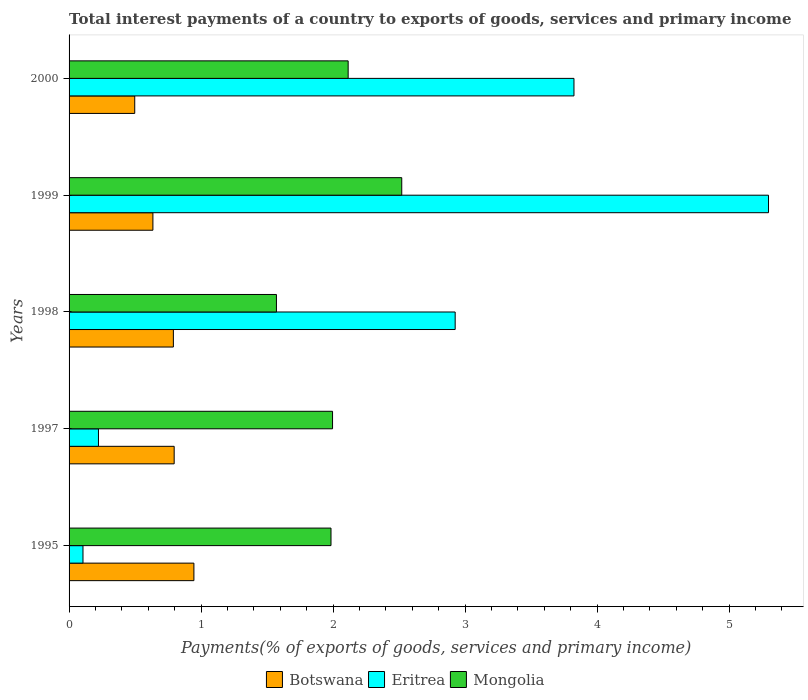How many different coloured bars are there?
Make the answer very short. 3. How many groups of bars are there?
Give a very brief answer. 5. Are the number of bars on each tick of the Y-axis equal?
Keep it short and to the point. Yes. How many bars are there on the 1st tick from the bottom?
Ensure brevity in your answer.  3. What is the total interest payments in Eritrea in 1995?
Provide a succinct answer. 0.11. Across all years, what is the maximum total interest payments in Mongolia?
Give a very brief answer. 2.52. Across all years, what is the minimum total interest payments in Mongolia?
Give a very brief answer. 1.57. In which year was the total interest payments in Mongolia maximum?
Your response must be concise. 1999. What is the total total interest payments in Eritrea in the graph?
Provide a short and direct response. 12.38. What is the difference between the total interest payments in Eritrea in 1998 and that in 2000?
Offer a terse response. -0.9. What is the difference between the total interest payments in Mongolia in 2000 and the total interest payments in Eritrea in 1995?
Keep it short and to the point. 2.01. What is the average total interest payments in Botswana per year?
Offer a very short reply. 0.73. In the year 1999, what is the difference between the total interest payments in Botswana and total interest payments in Eritrea?
Ensure brevity in your answer.  -4.66. What is the ratio of the total interest payments in Eritrea in 1997 to that in 2000?
Make the answer very short. 0.06. Is the total interest payments in Eritrea in 1997 less than that in 1998?
Your answer should be very brief. Yes. Is the difference between the total interest payments in Botswana in 1997 and 2000 greater than the difference between the total interest payments in Eritrea in 1997 and 2000?
Ensure brevity in your answer.  Yes. What is the difference between the highest and the second highest total interest payments in Botswana?
Your answer should be very brief. 0.15. What is the difference between the highest and the lowest total interest payments in Botswana?
Provide a short and direct response. 0.45. In how many years, is the total interest payments in Eritrea greater than the average total interest payments in Eritrea taken over all years?
Offer a terse response. 3. What does the 3rd bar from the top in 1995 represents?
Ensure brevity in your answer.  Botswana. What does the 1st bar from the bottom in 2000 represents?
Your answer should be compact. Botswana. Are all the bars in the graph horizontal?
Your answer should be very brief. Yes. How many years are there in the graph?
Give a very brief answer. 5. Are the values on the major ticks of X-axis written in scientific E-notation?
Keep it short and to the point. No. Does the graph contain any zero values?
Your answer should be very brief. No. What is the title of the graph?
Your answer should be very brief. Total interest payments of a country to exports of goods, services and primary income. Does "Paraguay" appear as one of the legend labels in the graph?
Provide a succinct answer. No. What is the label or title of the X-axis?
Provide a short and direct response. Payments(% of exports of goods, services and primary income). What is the Payments(% of exports of goods, services and primary income) in Botswana in 1995?
Provide a short and direct response. 0.95. What is the Payments(% of exports of goods, services and primary income) of Eritrea in 1995?
Offer a very short reply. 0.11. What is the Payments(% of exports of goods, services and primary income) of Mongolia in 1995?
Make the answer very short. 1.98. What is the Payments(% of exports of goods, services and primary income) in Botswana in 1997?
Your answer should be compact. 0.8. What is the Payments(% of exports of goods, services and primary income) in Eritrea in 1997?
Provide a short and direct response. 0.22. What is the Payments(% of exports of goods, services and primary income) in Mongolia in 1997?
Your response must be concise. 2. What is the Payments(% of exports of goods, services and primary income) of Botswana in 1998?
Keep it short and to the point. 0.79. What is the Payments(% of exports of goods, services and primary income) in Eritrea in 1998?
Give a very brief answer. 2.92. What is the Payments(% of exports of goods, services and primary income) of Mongolia in 1998?
Ensure brevity in your answer.  1.57. What is the Payments(% of exports of goods, services and primary income) in Botswana in 1999?
Provide a succinct answer. 0.64. What is the Payments(% of exports of goods, services and primary income) in Eritrea in 1999?
Your answer should be very brief. 5.3. What is the Payments(% of exports of goods, services and primary income) of Mongolia in 1999?
Your response must be concise. 2.52. What is the Payments(% of exports of goods, services and primary income) of Botswana in 2000?
Provide a short and direct response. 0.5. What is the Payments(% of exports of goods, services and primary income) of Eritrea in 2000?
Provide a succinct answer. 3.82. What is the Payments(% of exports of goods, services and primary income) in Mongolia in 2000?
Provide a succinct answer. 2.11. Across all years, what is the maximum Payments(% of exports of goods, services and primary income) in Botswana?
Your response must be concise. 0.95. Across all years, what is the maximum Payments(% of exports of goods, services and primary income) in Eritrea?
Your response must be concise. 5.3. Across all years, what is the maximum Payments(% of exports of goods, services and primary income) of Mongolia?
Give a very brief answer. 2.52. Across all years, what is the minimum Payments(% of exports of goods, services and primary income) in Botswana?
Offer a terse response. 0.5. Across all years, what is the minimum Payments(% of exports of goods, services and primary income) in Eritrea?
Give a very brief answer. 0.11. Across all years, what is the minimum Payments(% of exports of goods, services and primary income) in Mongolia?
Provide a short and direct response. 1.57. What is the total Payments(% of exports of goods, services and primary income) of Botswana in the graph?
Keep it short and to the point. 3.66. What is the total Payments(% of exports of goods, services and primary income) in Eritrea in the graph?
Give a very brief answer. 12.38. What is the total Payments(% of exports of goods, services and primary income) of Mongolia in the graph?
Make the answer very short. 10.19. What is the difference between the Payments(% of exports of goods, services and primary income) of Botswana in 1995 and that in 1997?
Provide a succinct answer. 0.15. What is the difference between the Payments(% of exports of goods, services and primary income) in Eritrea in 1995 and that in 1997?
Your response must be concise. -0.12. What is the difference between the Payments(% of exports of goods, services and primary income) in Mongolia in 1995 and that in 1997?
Provide a succinct answer. -0.01. What is the difference between the Payments(% of exports of goods, services and primary income) of Botswana in 1995 and that in 1998?
Your response must be concise. 0.16. What is the difference between the Payments(% of exports of goods, services and primary income) in Eritrea in 1995 and that in 1998?
Offer a terse response. -2.82. What is the difference between the Payments(% of exports of goods, services and primary income) of Mongolia in 1995 and that in 1998?
Give a very brief answer. 0.41. What is the difference between the Payments(% of exports of goods, services and primary income) of Botswana in 1995 and that in 1999?
Your answer should be compact. 0.31. What is the difference between the Payments(% of exports of goods, services and primary income) of Eritrea in 1995 and that in 1999?
Provide a short and direct response. -5.19. What is the difference between the Payments(% of exports of goods, services and primary income) in Mongolia in 1995 and that in 1999?
Offer a very short reply. -0.54. What is the difference between the Payments(% of exports of goods, services and primary income) in Botswana in 1995 and that in 2000?
Ensure brevity in your answer.  0.45. What is the difference between the Payments(% of exports of goods, services and primary income) of Eritrea in 1995 and that in 2000?
Make the answer very short. -3.72. What is the difference between the Payments(% of exports of goods, services and primary income) in Mongolia in 1995 and that in 2000?
Make the answer very short. -0.13. What is the difference between the Payments(% of exports of goods, services and primary income) in Botswana in 1997 and that in 1998?
Make the answer very short. 0.01. What is the difference between the Payments(% of exports of goods, services and primary income) in Eritrea in 1997 and that in 1998?
Your answer should be compact. -2.7. What is the difference between the Payments(% of exports of goods, services and primary income) of Mongolia in 1997 and that in 1998?
Your answer should be compact. 0.43. What is the difference between the Payments(% of exports of goods, services and primary income) in Botswana in 1997 and that in 1999?
Offer a terse response. 0.16. What is the difference between the Payments(% of exports of goods, services and primary income) of Eritrea in 1997 and that in 1999?
Offer a terse response. -5.08. What is the difference between the Payments(% of exports of goods, services and primary income) of Mongolia in 1997 and that in 1999?
Make the answer very short. -0.52. What is the difference between the Payments(% of exports of goods, services and primary income) in Botswana in 1997 and that in 2000?
Your answer should be compact. 0.3. What is the difference between the Payments(% of exports of goods, services and primary income) in Eritrea in 1997 and that in 2000?
Provide a short and direct response. -3.6. What is the difference between the Payments(% of exports of goods, services and primary income) of Mongolia in 1997 and that in 2000?
Your answer should be very brief. -0.12. What is the difference between the Payments(% of exports of goods, services and primary income) in Botswana in 1998 and that in 1999?
Make the answer very short. 0.16. What is the difference between the Payments(% of exports of goods, services and primary income) in Eritrea in 1998 and that in 1999?
Your answer should be very brief. -2.37. What is the difference between the Payments(% of exports of goods, services and primary income) of Mongolia in 1998 and that in 1999?
Offer a very short reply. -0.95. What is the difference between the Payments(% of exports of goods, services and primary income) of Botswana in 1998 and that in 2000?
Offer a terse response. 0.29. What is the difference between the Payments(% of exports of goods, services and primary income) of Eritrea in 1998 and that in 2000?
Offer a very short reply. -0.9. What is the difference between the Payments(% of exports of goods, services and primary income) of Mongolia in 1998 and that in 2000?
Your response must be concise. -0.54. What is the difference between the Payments(% of exports of goods, services and primary income) in Botswana in 1999 and that in 2000?
Your answer should be compact. 0.14. What is the difference between the Payments(% of exports of goods, services and primary income) of Eritrea in 1999 and that in 2000?
Ensure brevity in your answer.  1.47. What is the difference between the Payments(% of exports of goods, services and primary income) of Mongolia in 1999 and that in 2000?
Provide a succinct answer. 0.41. What is the difference between the Payments(% of exports of goods, services and primary income) in Botswana in 1995 and the Payments(% of exports of goods, services and primary income) in Eritrea in 1997?
Your answer should be very brief. 0.72. What is the difference between the Payments(% of exports of goods, services and primary income) of Botswana in 1995 and the Payments(% of exports of goods, services and primary income) of Mongolia in 1997?
Offer a terse response. -1.05. What is the difference between the Payments(% of exports of goods, services and primary income) of Eritrea in 1995 and the Payments(% of exports of goods, services and primary income) of Mongolia in 1997?
Make the answer very short. -1.89. What is the difference between the Payments(% of exports of goods, services and primary income) of Botswana in 1995 and the Payments(% of exports of goods, services and primary income) of Eritrea in 1998?
Offer a very short reply. -1.98. What is the difference between the Payments(% of exports of goods, services and primary income) of Botswana in 1995 and the Payments(% of exports of goods, services and primary income) of Mongolia in 1998?
Your answer should be compact. -0.63. What is the difference between the Payments(% of exports of goods, services and primary income) of Eritrea in 1995 and the Payments(% of exports of goods, services and primary income) of Mongolia in 1998?
Keep it short and to the point. -1.47. What is the difference between the Payments(% of exports of goods, services and primary income) of Botswana in 1995 and the Payments(% of exports of goods, services and primary income) of Eritrea in 1999?
Keep it short and to the point. -4.35. What is the difference between the Payments(% of exports of goods, services and primary income) in Botswana in 1995 and the Payments(% of exports of goods, services and primary income) in Mongolia in 1999?
Provide a short and direct response. -1.57. What is the difference between the Payments(% of exports of goods, services and primary income) in Eritrea in 1995 and the Payments(% of exports of goods, services and primary income) in Mongolia in 1999?
Provide a succinct answer. -2.41. What is the difference between the Payments(% of exports of goods, services and primary income) in Botswana in 1995 and the Payments(% of exports of goods, services and primary income) in Eritrea in 2000?
Provide a succinct answer. -2.88. What is the difference between the Payments(% of exports of goods, services and primary income) of Botswana in 1995 and the Payments(% of exports of goods, services and primary income) of Mongolia in 2000?
Offer a very short reply. -1.17. What is the difference between the Payments(% of exports of goods, services and primary income) in Eritrea in 1995 and the Payments(% of exports of goods, services and primary income) in Mongolia in 2000?
Offer a terse response. -2.01. What is the difference between the Payments(% of exports of goods, services and primary income) in Botswana in 1997 and the Payments(% of exports of goods, services and primary income) in Eritrea in 1998?
Your answer should be very brief. -2.13. What is the difference between the Payments(% of exports of goods, services and primary income) of Botswana in 1997 and the Payments(% of exports of goods, services and primary income) of Mongolia in 1998?
Offer a terse response. -0.77. What is the difference between the Payments(% of exports of goods, services and primary income) in Eritrea in 1997 and the Payments(% of exports of goods, services and primary income) in Mongolia in 1998?
Your answer should be very brief. -1.35. What is the difference between the Payments(% of exports of goods, services and primary income) in Botswana in 1997 and the Payments(% of exports of goods, services and primary income) in Eritrea in 1999?
Provide a short and direct response. -4.5. What is the difference between the Payments(% of exports of goods, services and primary income) of Botswana in 1997 and the Payments(% of exports of goods, services and primary income) of Mongolia in 1999?
Ensure brevity in your answer.  -1.72. What is the difference between the Payments(% of exports of goods, services and primary income) of Eritrea in 1997 and the Payments(% of exports of goods, services and primary income) of Mongolia in 1999?
Offer a terse response. -2.3. What is the difference between the Payments(% of exports of goods, services and primary income) of Botswana in 1997 and the Payments(% of exports of goods, services and primary income) of Eritrea in 2000?
Your response must be concise. -3.03. What is the difference between the Payments(% of exports of goods, services and primary income) of Botswana in 1997 and the Payments(% of exports of goods, services and primary income) of Mongolia in 2000?
Provide a short and direct response. -1.32. What is the difference between the Payments(% of exports of goods, services and primary income) of Eritrea in 1997 and the Payments(% of exports of goods, services and primary income) of Mongolia in 2000?
Keep it short and to the point. -1.89. What is the difference between the Payments(% of exports of goods, services and primary income) in Botswana in 1998 and the Payments(% of exports of goods, services and primary income) in Eritrea in 1999?
Your response must be concise. -4.51. What is the difference between the Payments(% of exports of goods, services and primary income) of Botswana in 1998 and the Payments(% of exports of goods, services and primary income) of Mongolia in 1999?
Make the answer very short. -1.73. What is the difference between the Payments(% of exports of goods, services and primary income) in Eritrea in 1998 and the Payments(% of exports of goods, services and primary income) in Mongolia in 1999?
Offer a very short reply. 0.4. What is the difference between the Payments(% of exports of goods, services and primary income) in Botswana in 1998 and the Payments(% of exports of goods, services and primary income) in Eritrea in 2000?
Your answer should be compact. -3.03. What is the difference between the Payments(% of exports of goods, services and primary income) of Botswana in 1998 and the Payments(% of exports of goods, services and primary income) of Mongolia in 2000?
Your response must be concise. -1.32. What is the difference between the Payments(% of exports of goods, services and primary income) in Eritrea in 1998 and the Payments(% of exports of goods, services and primary income) in Mongolia in 2000?
Keep it short and to the point. 0.81. What is the difference between the Payments(% of exports of goods, services and primary income) in Botswana in 1999 and the Payments(% of exports of goods, services and primary income) in Eritrea in 2000?
Your answer should be compact. -3.19. What is the difference between the Payments(% of exports of goods, services and primary income) in Botswana in 1999 and the Payments(% of exports of goods, services and primary income) in Mongolia in 2000?
Provide a short and direct response. -1.48. What is the difference between the Payments(% of exports of goods, services and primary income) in Eritrea in 1999 and the Payments(% of exports of goods, services and primary income) in Mongolia in 2000?
Keep it short and to the point. 3.18. What is the average Payments(% of exports of goods, services and primary income) of Botswana per year?
Your response must be concise. 0.73. What is the average Payments(% of exports of goods, services and primary income) of Eritrea per year?
Offer a very short reply. 2.48. What is the average Payments(% of exports of goods, services and primary income) of Mongolia per year?
Your answer should be very brief. 2.04. In the year 1995, what is the difference between the Payments(% of exports of goods, services and primary income) of Botswana and Payments(% of exports of goods, services and primary income) of Eritrea?
Ensure brevity in your answer.  0.84. In the year 1995, what is the difference between the Payments(% of exports of goods, services and primary income) of Botswana and Payments(% of exports of goods, services and primary income) of Mongolia?
Give a very brief answer. -1.04. In the year 1995, what is the difference between the Payments(% of exports of goods, services and primary income) of Eritrea and Payments(% of exports of goods, services and primary income) of Mongolia?
Ensure brevity in your answer.  -1.88. In the year 1997, what is the difference between the Payments(% of exports of goods, services and primary income) in Botswana and Payments(% of exports of goods, services and primary income) in Eritrea?
Ensure brevity in your answer.  0.57. In the year 1997, what is the difference between the Payments(% of exports of goods, services and primary income) of Botswana and Payments(% of exports of goods, services and primary income) of Mongolia?
Your answer should be compact. -1.2. In the year 1997, what is the difference between the Payments(% of exports of goods, services and primary income) of Eritrea and Payments(% of exports of goods, services and primary income) of Mongolia?
Offer a terse response. -1.77. In the year 1998, what is the difference between the Payments(% of exports of goods, services and primary income) in Botswana and Payments(% of exports of goods, services and primary income) in Eritrea?
Your response must be concise. -2.13. In the year 1998, what is the difference between the Payments(% of exports of goods, services and primary income) of Botswana and Payments(% of exports of goods, services and primary income) of Mongolia?
Offer a terse response. -0.78. In the year 1998, what is the difference between the Payments(% of exports of goods, services and primary income) in Eritrea and Payments(% of exports of goods, services and primary income) in Mongolia?
Your answer should be compact. 1.35. In the year 1999, what is the difference between the Payments(% of exports of goods, services and primary income) of Botswana and Payments(% of exports of goods, services and primary income) of Eritrea?
Provide a succinct answer. -4.66. In the year 1999, what is the difference between the Payments(% of exports of goods, services and primary income) of Botswana and Payments(% of exports of goods, services and primary income) of Mongolia?
Your answer should be very brief. -1.89. In the year 1999, what is the difference between the Payments(% of exports of goods, services and primary income) in Eritrea and Payments(% of exports of goods, services and primary income) in Mongolia?
Provide a short and direct response. 2.78. In the year 2000, what is the difference between the Payments(% of exports of goods, services and primary income) of Botswana and Payments(% of exports of goods, services and primary income) of Eritrea?
Ensure brevity in your answer.  -3.33. In the year 2000, what is the difference between the Payments(% of exports of goods, services and primary income) of Botswana and Payments(% of exports of goods, services and primary income) of Mongolia?
Your answer should be compact. -1.62. In the year 2000, what is the difference between the Payments(% of exports of goods, services and primary income) of Eritrea and Payments(% of exports of goods, services and primary income) of Mongolia?
Make the answer very short. 1.71. What is the ratio of the Payments(% of exports of goods, services and primary income) of Botswana in 1995 to that in 1997?
Offer a terse response. 1.19. What is the ratio of the Payments(% of exports of goods, services and primary income) in Eritrea in 1995 to that in 1997?
Provide a succinct answer. 0.47. What is the ratio of the Payments(% of exports of goods, services and primary income) in Mongolia in 1995 to that in 1997?
Your answer should be compact. 0.99. What is the ratio of the Payments(% of exports of goods, services and primary income) of Botswana in 1995 to that in 1998?
Ensure brevity in your answer.  1.2. What is the ratio of the Payments(% of exports of goods, services and primary income) in Eritrea in 1995 to that in 1998?
Provide a succinct answer. 0.04. What is the ratio of the Payments(% of exports of goods, services and primary income) in Mongolia in 1995 to that in 1998?
Offer a very short reply. 1.26. What is the ratio of the Payments(% of exports of goods, services and primary income) in Botswana in 1995 to that in 1999?
Keep it short and to the point. 1.49. What is the ratio of the Payments(% of exports of goods, services and primary income) in Eritrea in 1995 to that in 1999?
Your answer should be compact. 0.02. What is the ratio of the Payments(% of exports of goods, services and primary income) in Mongolia in 1995 to that in 1999?
Keep it short and to the point. 0.79. What is the ratio of the Payments(% of exports of goods, services and primary income) of Botswana in 1995 to that in 2000?
Provide a succinct answer. 1.9. What is the ratio of the Payments(% of exports of goods, services and primary income) in Eritrea in 1995 to that in 2000?
Offer a terse response. 0.03. What is the ratio of the Payments(% of exports of goods, services and primary income) in Mongolia in 1995 to that in 2000?
Your response must be concise. 0.94. What is the ratio of the Payments(% of exports of goods, services and primary income) in Botswana in 1997 to that in 1998?
Make the answer very short. 1.01. What is the ratio of the Payments(% of exports of goods, services and primary income) of Eritrea in 1997 to that in 1998?
Your response must be concise. 0.08. What is the ratio of the Payments(% of exports of goods, services and primary income) of Mongolia in 1997 to that in 1998?
Offer a terse response. 1.27. What is the ratio of the Payments(% of exports of goods, services and primary income) of Botswana in 1997 to that in 1999?
Provide a succinct answer. 1.25. What is the ratio of the Payments(% of exports of goods, services and primary income) of Eritrea in 1997 to that in 1999?
Provide a succinct answer. 0.04. What is the ratio of the Payments(% of exports of goods, services and primary income) in Mongolia in 1997 to that in 1999?
Give a very brief answer. 0.79. What is the ratio of the Payments(% of exports of goods, services and primary income) of Botswana in 1997 to that in 2000?
Provide a short and direct response. 1.6. What is the ratio of the Payments(% of exports of goods, services and primary income) in Eritrea in 1997 to that in 2000?
Provide a short and direct response. 0.06. What is the ratio of the Payments(% of exports of goods, services and primary income) in Mongolia in 1997 to that in 2000?
Offer a very short reply. 0.94. What is the ratio of the Payments(% of exports of goods, services and primary income) of Botswana in 1998 to that in 1999?
Ensure brevity in your answer.  1.24. What is the ratio of the Payments(% of exports of goods, services and primary income) of Eritrea in 1998 to that in 1999?
Your response must be concise. 0.55. What is the ratio of the Payments(% of exports of goods, services and primary income) in Mongolia in 1998 to that in 1999?
Your answer should be compact. 0.62. What is the ratio of the Payments(% of exports of goods, services and primary income) in Botswana in 1998 to that in 2000?
Your answer should be very brief. 1.59. What is the ratio of the Payments(% of exports of goods, services and primary income) of Eritrea in 1998 to that in 2000?
Your answer should be very brief. 0.76. What is the ratio of the Payments(% of exports of goods, services and primary income) of Mongolia in 1998 to that in 2000?
Your answer should be compact. 0.74. What is the ratio of the Payments(% of exports of goods, services and primary income) of Botswana in 1999 to that in 2000?
Your answer should be compact. 1.28. What is the ratio of the Payments(% of exports of goods, services and primary income) of Eritrea in 1999 to that in 2000?
Your response must be concise. 1.39. What is the ratio of the Payments(% of exports of goods, services and primary income) of Mongolia in 1999 to that in 2000?
Keep it short and to the point. 1.19. What is the difference between the highest and the second highest Payments(% of exports of goods, services and primary income) in Botswana?
Ensure brevity in your answer.  0.15. What is the difference between the highest and the second highest Payments(% of exports of goods, services and primary income) in Eritrea?
Your answer should be very brief. 1.47. What is the difference between the highest and the second highest Payments(% of exports of goods, services and primary income) of Mongolia?
Give a very brief answer. 0.41. What is the difference between the highest and the lowest Payments(% of exports of goods, services and primary income) of Botswana?
Your response must be concise. 0.45. What is the difference between the highest and the lowest Payments(% of exports of goods, services and primary income) of Eritrea?
Offer a very short reply. 5.19. What is the difference between the highest and the lowest Payments(% of exports of goods, services and primary income) of Mongolia?
Your answer should be compact. 0.95. 